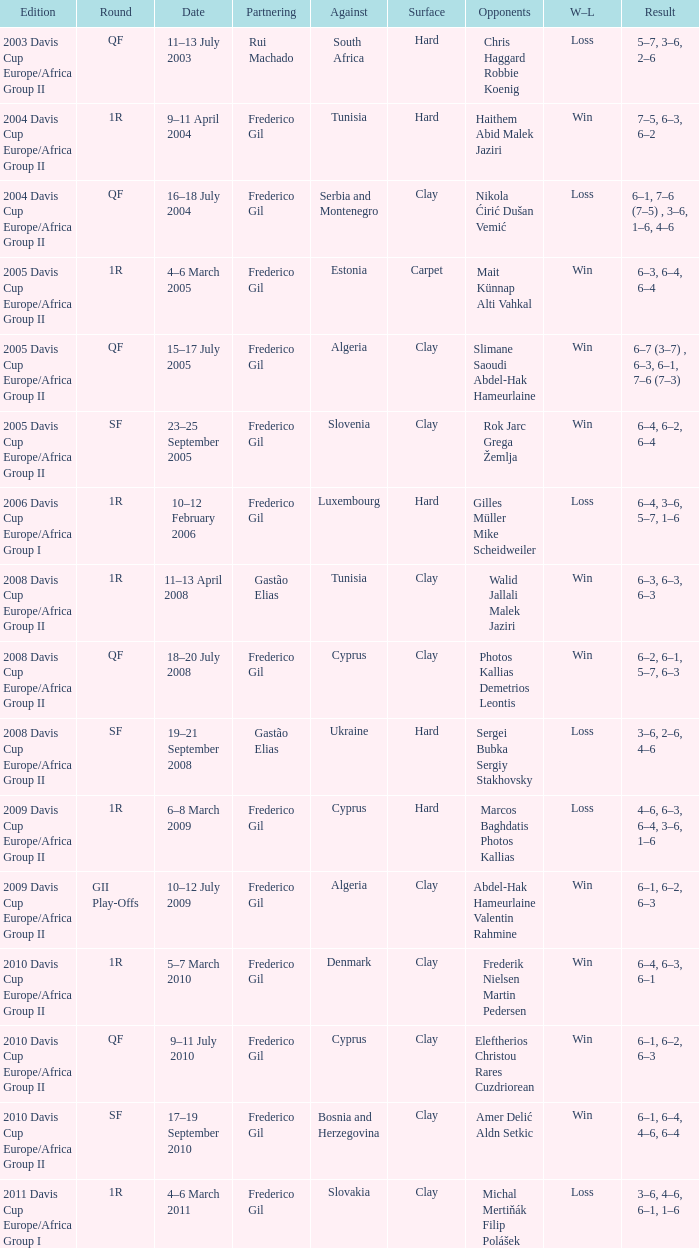How many rounds were there in the 2006 davis cup europe/africa group I? 1.0. 